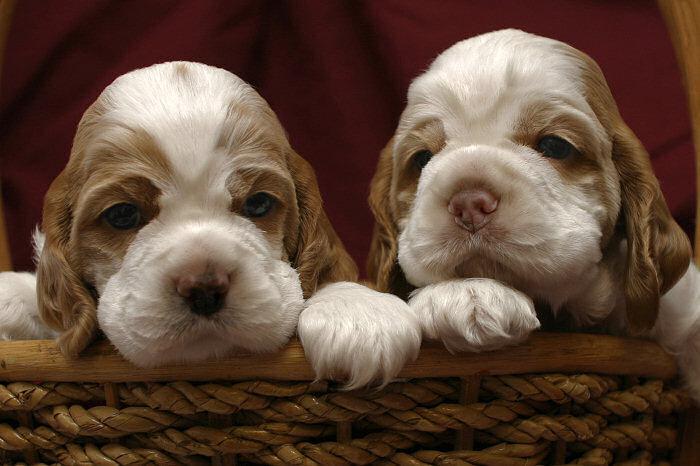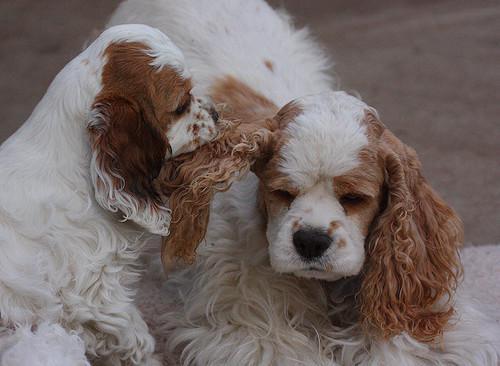The first image is the image on the left, the second image is the image on the right. Assess this claim about the two images: "A single puppy is lying on a carpet in one of the images.". Correct or not? Answer yes or no. No. 